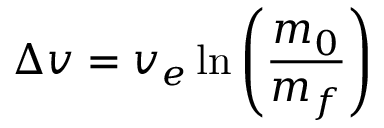Convert formula to latex. <formula><loc_0><loc_0><loc_500><loc_500>\Delta v = v _ { e } \ln \left ( \frac { m _ { 0 } } { m _ { f } } \right )</formula> 